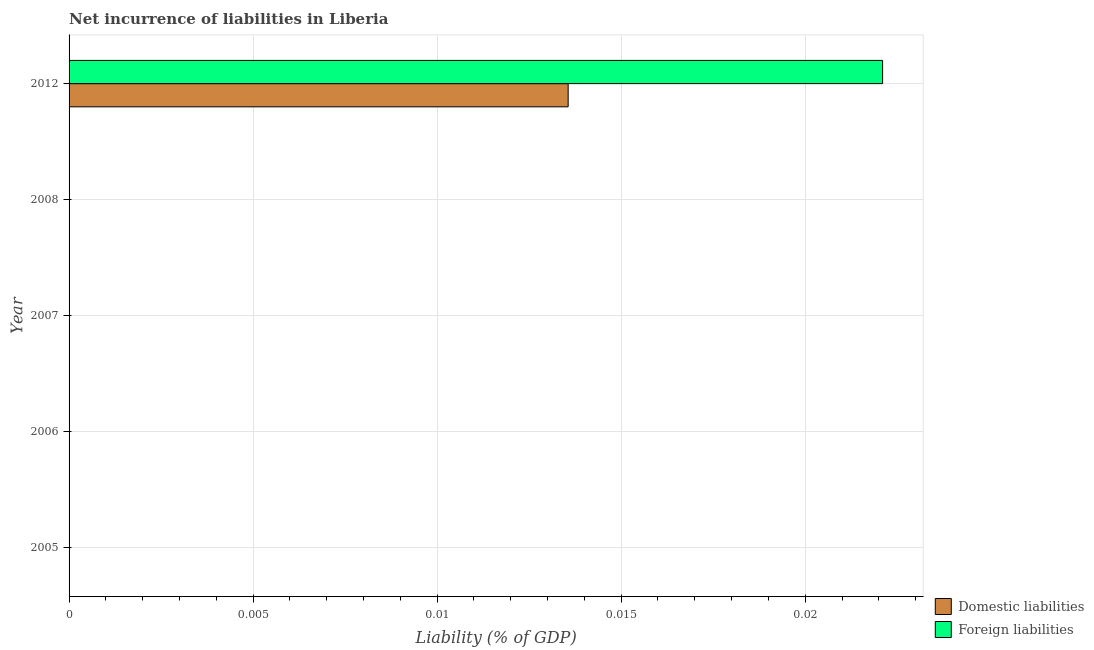Are the number of bars per tick equal to the number of legend labels?
Keep it short and to the point. No. Are the number of bars on each tick of the Y-axis equal?
Your answer should be compact. No. What is the label of the 2nd group of bars from the top?
Offer a terse response. 2008. What is the incurrence of domestic liabilities in 2005?
Keep it short and to the point. 0. Across all years, what is the maximum incurrence of foreign liabilities?
Provide a short and direct response. 0.02. What is the total incurrence of foreign liabilities in the graph?
Provide a short and direct response. 0.02. What is the difference between the incurrence of foreign liabilities in 2006 and the incurrence of domestic liabilities in 2005?
Your response must be concise. 0. What is the average incurrence of domestic liabilities per year?
Offer a very short reply. 0. In the year 2012, what is the difference between the incurrence of foreign liabilities and incurrence of domestic liabilities?
Your response must be concise. 0.01. In how many years, is the incurrence of foreign liabilities greater than 0.015 %?
Your answer should be very brief. 1. How many years are there in the graph?
Offer a very short reply. 5. What is the difference between two consecutive major ticks on the X-axis?
Your answer should be very brief. 0.01. Are the values on the major ticks of X-axis written in scientific E-notation?
Provide a short and direct response. No. Does the graph contain grids?
Make the answer very short. Yes. How are the legend labels stacked?
Your answer should be very brief. Vertical. What is the title of the graph?
Offer a very short reply. Net incurrence of liabilities in Liberia. What is the label or title of the X-axis?
Offer a terse response. Liability (% of GDP). What is the label or title of the Y-axis?
Ensure brevity in your answer.  Year. What is the Liability (% of GDP) of Domestic liabilities in 2005?
Make the answer very short. 0. What is the Liability (% of GDP) of Domestic liabilities in 2006?
Make the answer very short. 0. What is the Liability (% of GDP) of Foreign liabilities in 2007?
Make the answer very short. 0. What is the Liability (% of GDP) in Domestic liabilities in 2012?
Your response must be concise. 0.01. What is the Liability (% of GDP) in Foreign liabilities in 2012?
Your answer should be compact. 0.02. Across all years, what is the maximum Liability (% of GDP) in Domestic liabilities?
Your answer should be compact. 0.01. Across all years, what is the maximum Liability (% of GDP) of Foreign liabilities?
Your answer should be very brief. 0.02. Across all years, what is the minimum Liability (% of GDP) of Foreign liabilities?
Your answer should be very brief. 0. What is the total Liability (% of GDP) of Domestic liabilities in the graph?
Give a very brief answer. 0.01. What is the total Liability (% of GDP) of Foreign liabilities in the graph?
Your response must be concise. 0.02. What is the average Liability (% of GDP) of Domestic liabilities per year?
Keep it short and to the point. 0. What is the average Liability (% of GDP) of Foreign liabilities per year?
Your response must be concise. 0. In the year 2012, what is the difference between the Liability (% of GDP) in Domestic liabilities and Liability (% of GDP) in Foreign liabilities?
Provide a short and direct response. -0.01. What is the difference between the highest and the lowest Liability (% of GDP) of Domestic liabilities?
Offer a terse response. 0.01. What is the difference between the highest and the lowest Liability (% of GDP) of Foreign liabilities?
Ensure brevity in your answer.  0.02. 